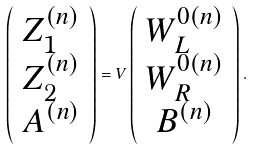Convert formula to latex. <formula><loc_0><loc_0><loc_500><loc_500>\left ( \begin{array} { c } Z _ { 1 } ^ { ( n ) } \\ Z _ { 2 } ^ { ( n ) } \\ A ^ { ( n ) } \end{array} \right ) = V \left ( \begin{array} { c } W _ { L } ^ { 0 ( n ) } \\ W _ { R } ^ { 0 ( n ) } \\ B ^ { ( n ) } \end{array} \right ) .</formula> 